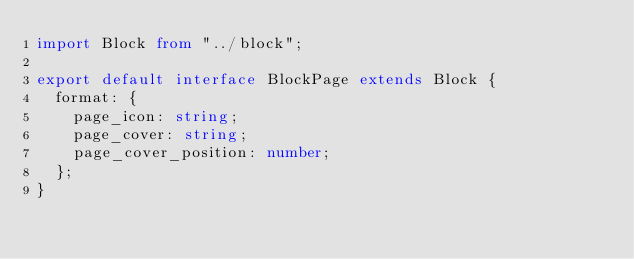<code> <loc_0><loc_0><loc_500><loc_500><_TypeScript_>import Block from "../block";

export default interface BlockPage extends Block {
  format: {
    page_icon: string;
    page_cover: string;
    page_cover_position: number;
  };
}
</code> 